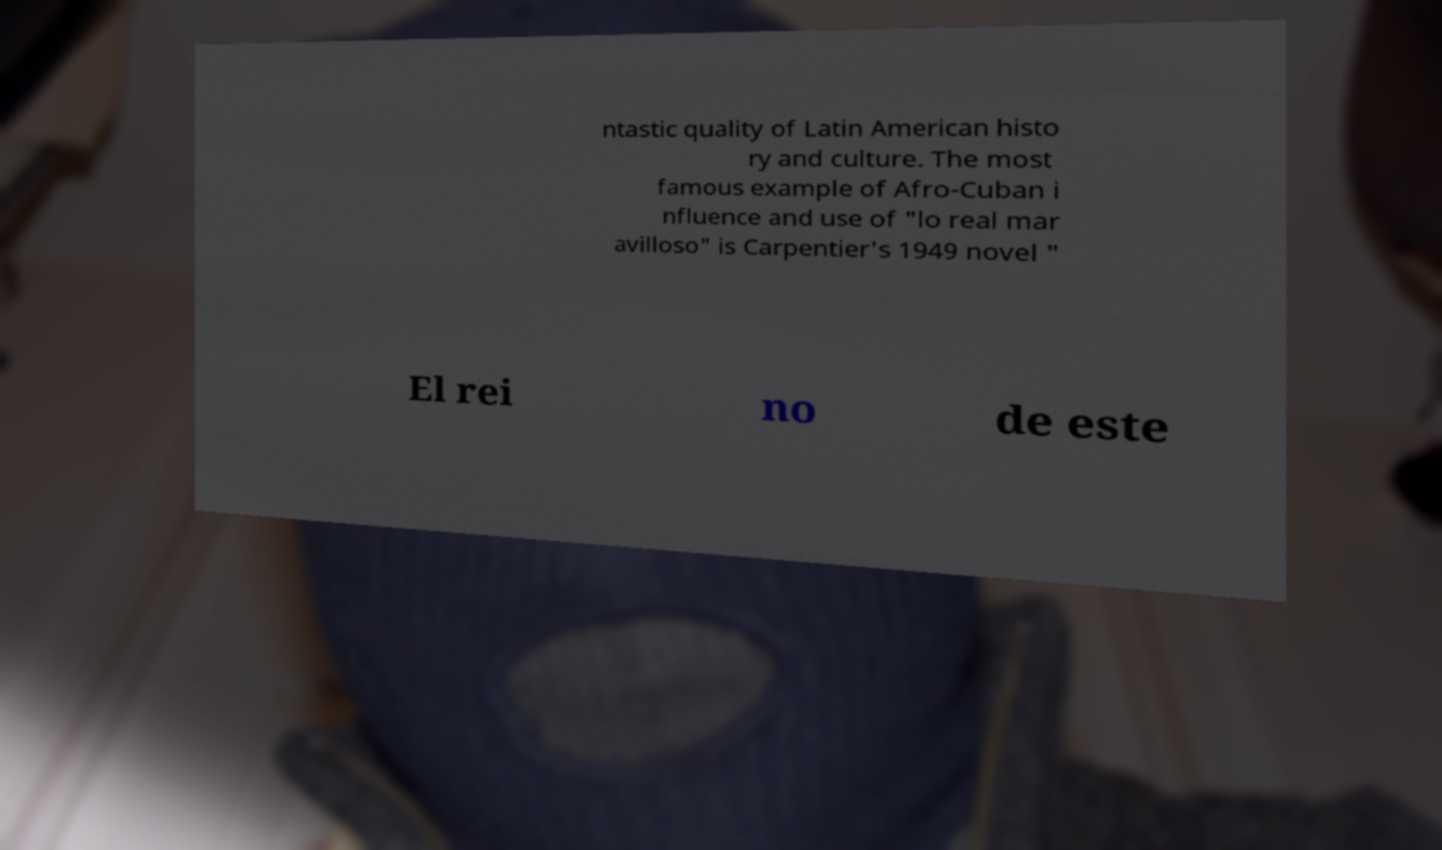Could you assist in decoding the text presented in this image and type it out clearly? ntastic quality of Latin American histo ry and culture. The most famous example of Afro-Cuban i nfluence and use of "lo real mar avilloso" is Carpentier's 1949 novel " El rei no de este 